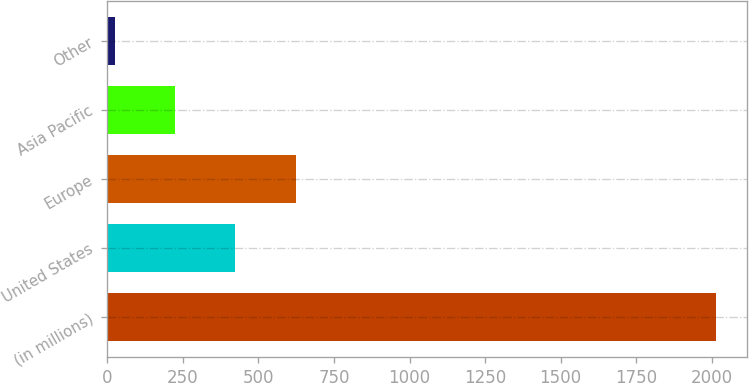<chart> <loc_0><loc_0><loc_500><loc_500><bar_chart><fcel>(in millions)<fcel>United States<fcel>Europe<fcel>Asia Pacific<fcel>Other<nl><fcel>2015<fcel>423.8<fcel>622.7<fcel>224.9<fcel>26<nl></chart> 